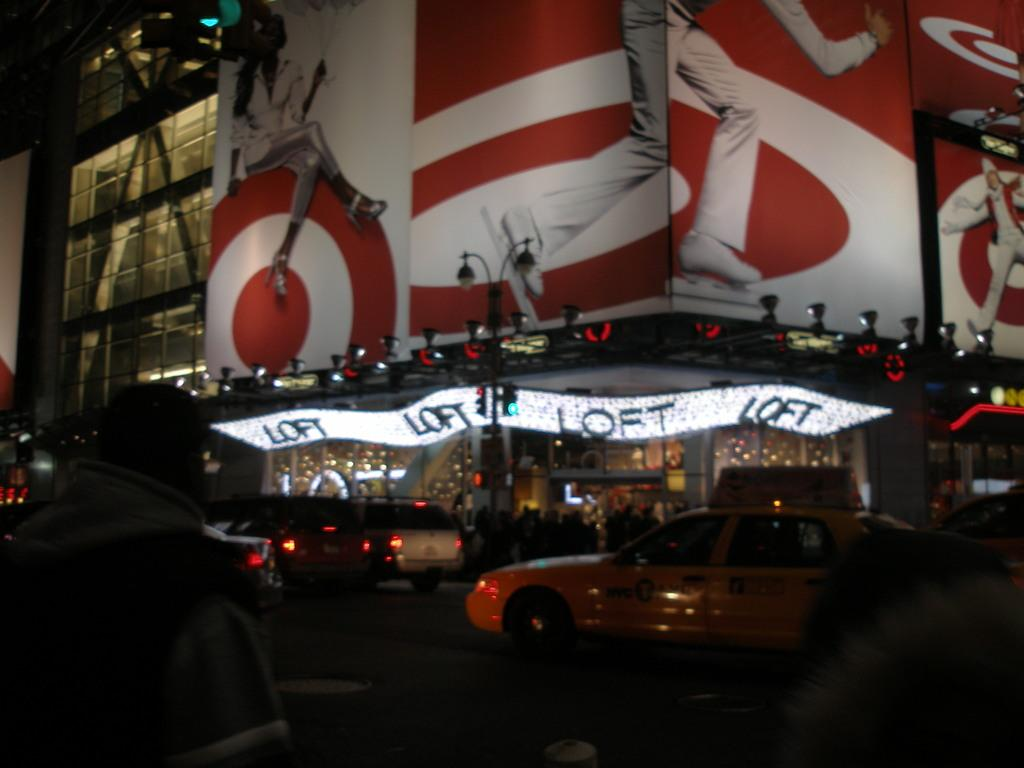<image>
Give a short and clear explanation of the subsequent image. A busy city street at night, a Loft hotel on the corner. 